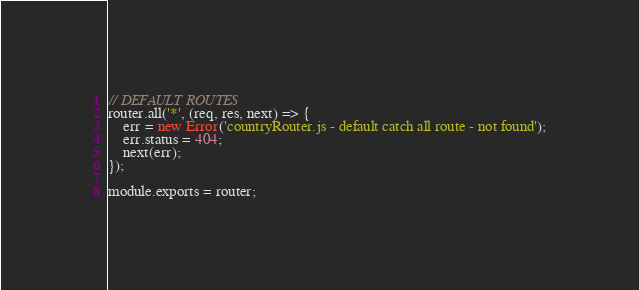<code> <loc_0><loc_0><loc_500><loc_500><_JavaScript_>// DEFAULT ROUTES
router.all('*', (req, res, next) => {
    err = new Error('countryRouter.js - default catch all route - not found');
    err.status = 404;
    next(err);
});

module.exports = router;
</code> 